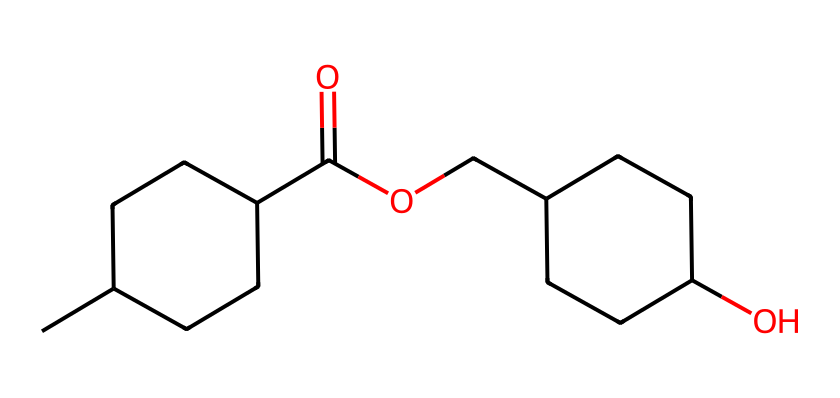What is the total number of carbon atoms in this chemical? In the provided SMILES, we can count the occurrences of "C". There are 10 carbon atoms in total in the structure.
Answer: 10 How many rings are present in this cycloalkane derivative? The structure contains two cycloalkane rings, indicated by the "CCC" segments where the carbon atoms are bonded in a circular formation.
Answer: 2 What functional groups are present in this chemical? By analyzing the SMILES notation, we find a carboxylic acid (C(=O)O) and an ether (OCC) functional group present in the structure.
Answer: carboxylic acid, ether Which part of the chemical contributes to its low VOC properties? The presence of oxygen-containing functional groups, such as the carboxylic acid and ether, typically leads to lower volatility and less harmful emissions compared to traditional hydrocarbon chains.
Answer: oxygen-containing functional groups Is this chemical a saturated or unsaturated cycloalkane derivative? The lack of double or triple bonds between carbon atoms and the presence of single bonds indicates that the structure is fully saturated.
Answer: saturated How many distinct cycloalkane structures are represented here? The SMILES has two distinct cycloalkane structures, as indicated by the two separate ringed carbon chains forming part of the overall molecule.
Answer: 2 